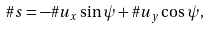<formula> <loc_0><loc_0><loc_500><loc_500>\# { s } = - \# { u } _ { x } \sin { \psi } + \# { u } _ { y } \cos { \psi } ,</formula> 